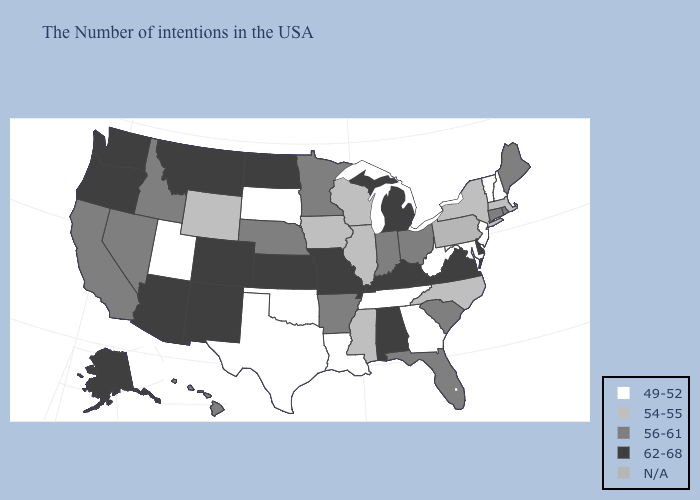Among the states that border California , which have the lowest value?
Give a very brief answer. Nevada. Among the states that border Maryland , which have the lowest value?
Answer briefly. West Virginia. Among the states that border Ohio , does West Virginia have the highest value?
Answer briefly. No. Among the states that border Arizona , does Nevada have the lowest value?
Be succinct. No. What is the highest value in the Northeast ?
Short answer required. 56-61. Among the states that border Wisconsin , which have the highest value?
Keep it brief. Michigan. Does Arizona have the lowest value in the USA?
Be succinct. No. Is the legend a continuous bar?
Write a very short answer. No. What is the value of New Hampshire?
Keep it brief. 49-52. What is the value of Florida?
Quick response, please. 56-61. What is the value of Colorado?
Quick response, please. 62-68. Which states have the lowest value in the MidWest?
Give a very brief answer. South Dakota. Among the states that border California , which have the lowest value?
Keep it brief. Nevada. What is the lowest value in the MidWest?
Answer briefly. 49-52. 